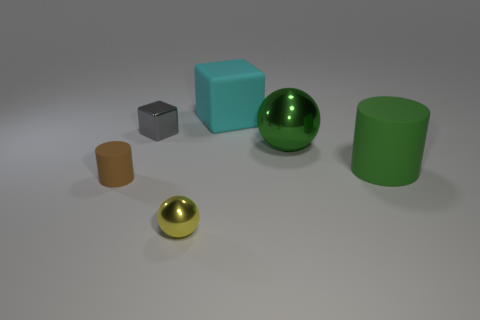Is the small cylinder the same color as the big ball?
Give a very brief answer. No. There is a block to the left of the rubber thing behind the gray object; what number of cubes are to the left of it?
Ensure brevity in your answer.  0. What material is the green object that is to the right of the metal ball right of the cyan rubber cube made of?
Your answer should be very brief. Rubber. Are there any yellow rubber things of the same shape as the small brown thing?
Your response must be concise. No. The cylinder that is the same size as the green shiny thing is what color?
Offer a very short reply. Green. How many objects are objects on the left side of the cyan matte block or tiny things on the right side of the gray shiny block?
Keep it short and to the point. 3. What number of things are cyan rubber spheres or large cyan rubber things?
Give a very brief answer. 1. How big is the rubber thing that is in front of the large cyan matte block and on the right side of the gray metal cube?
Ensure brevity in your answer.  Large. What number of other big cylinders have the same material as the large cylinder?
Give a very brief answer. 0. What is the color of the small block that is the same material as the tiny yellow sphere?
Your response must be concise. Gray. 